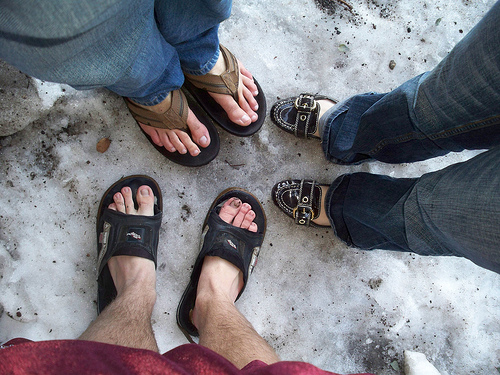<image>
Is the sandal on the loafer? No. The sandal is not positioned on the loafer. They may be near each other, but the sandal is not supported by or resting on top of the loafer. Where is the shoe in relation to the skin? Is it to the left of the skin? No. The shoe is not to the left of the skin. From this viewpoint, they have a different horizontal relationship. 